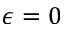<formula> <loc_0><loc_0><loc_500><loc_500>\epsilon = 0</formula> 